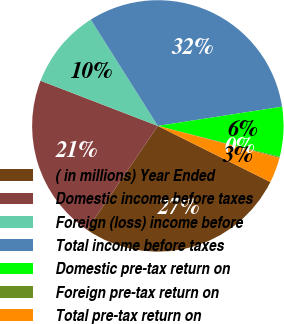Convert chart. <chart><loc_0><loc_0><loc_500><loc_500><pie_chart><fcel>( in millions) Year Ended<fcel>Domestic income before taxes<fcel>Foreign (loss) income before<fcel>Total income before taxes<fcel>Domestic pre-tax return on<fcel>Foreign pre-tax return on<fcel>Total pre-tax return on<nl><fcel>27.17%<fcel>21.32%<fcel>10.19%<fcel>31.51%<fcel>6.41%<fcel>0.13%<fcel>3.27%<nl></chart> 